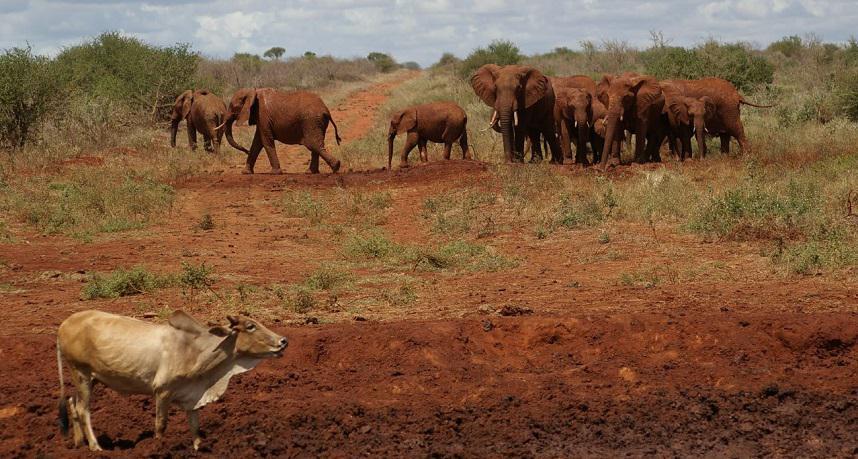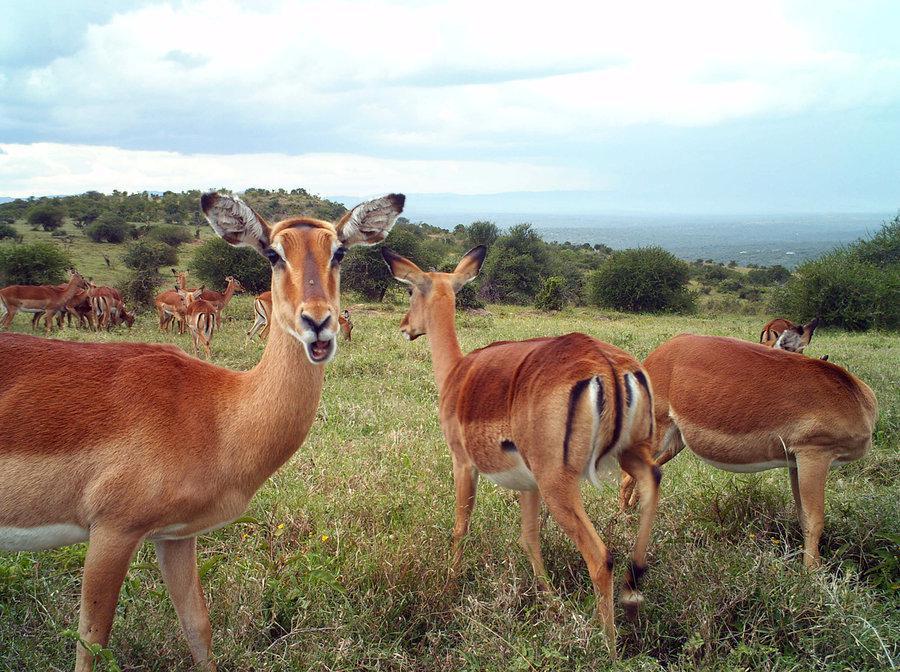The first image is the image on the left, the second image is the image on the right. For the images shown, is this caption "A herd of elephants mills about behind another type of animal." true? Answer yes or no. Yes. 